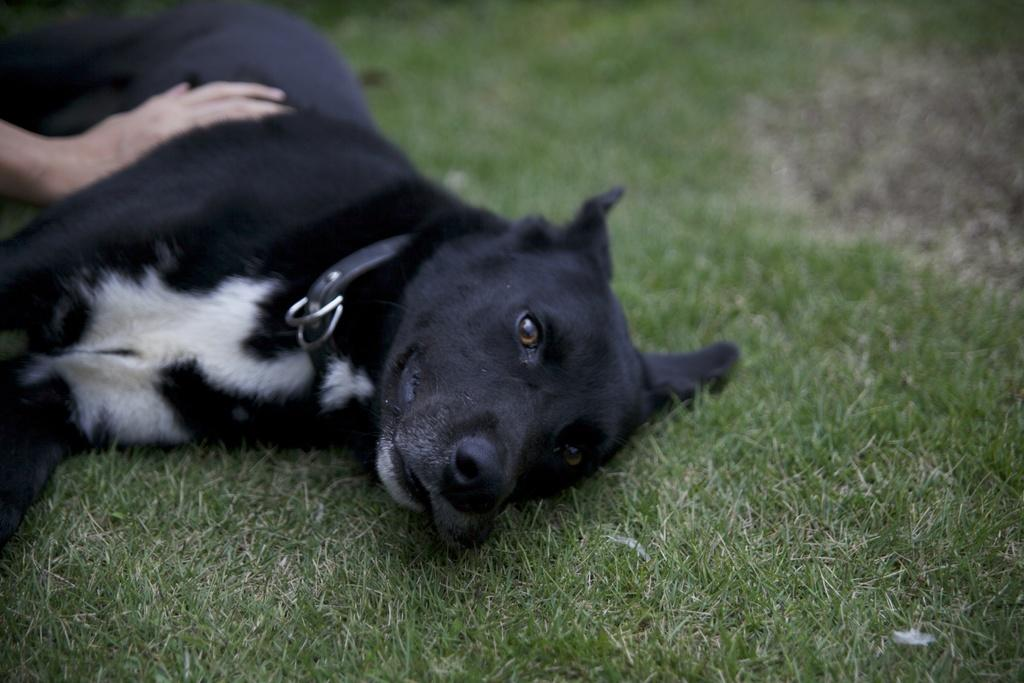What type of animal is present in the image? There is a dog in the image. Where is the dog located? The dog is on the grass. Can you describe any other elements in the image? There is a human hand visible in the top left corner of the image. What type of rings can be seen on the dog's paws in the image? There are no rings visible on the dog's paws in the image. Is the dog reading a book in the image? There is no indication in the image that the dog is reading a book. 